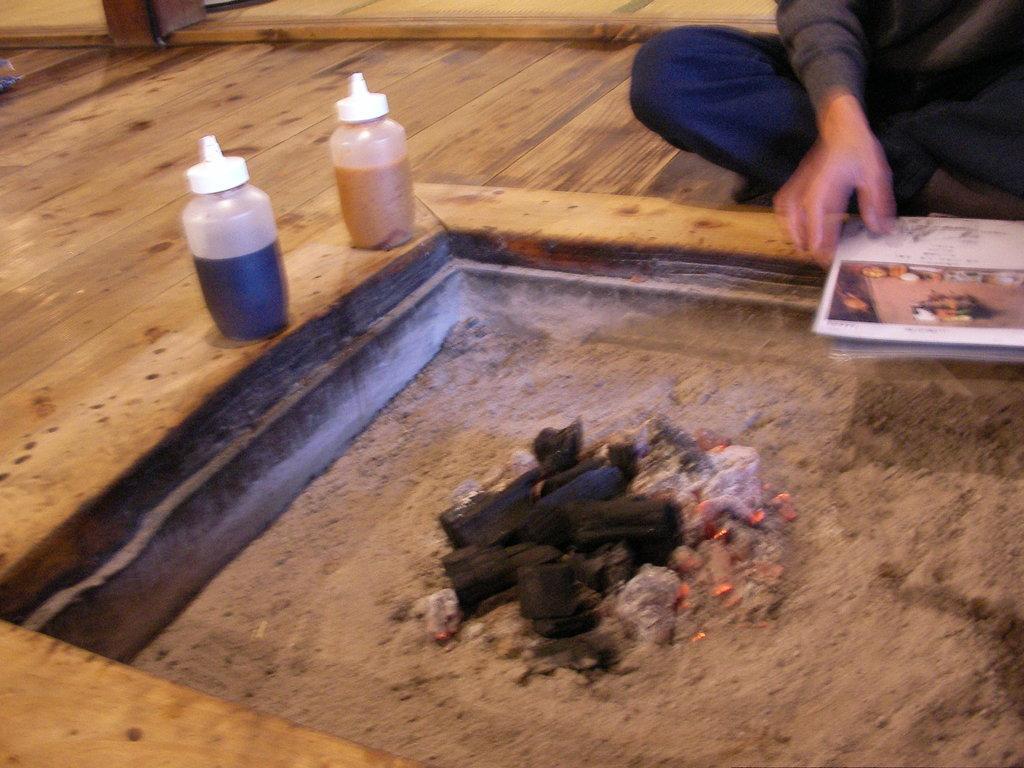Describe this image in one or two sentences. In this image I see a person who is sitting on the floor and holding a book. I can also see there are 2 bottles and some mud over here. 